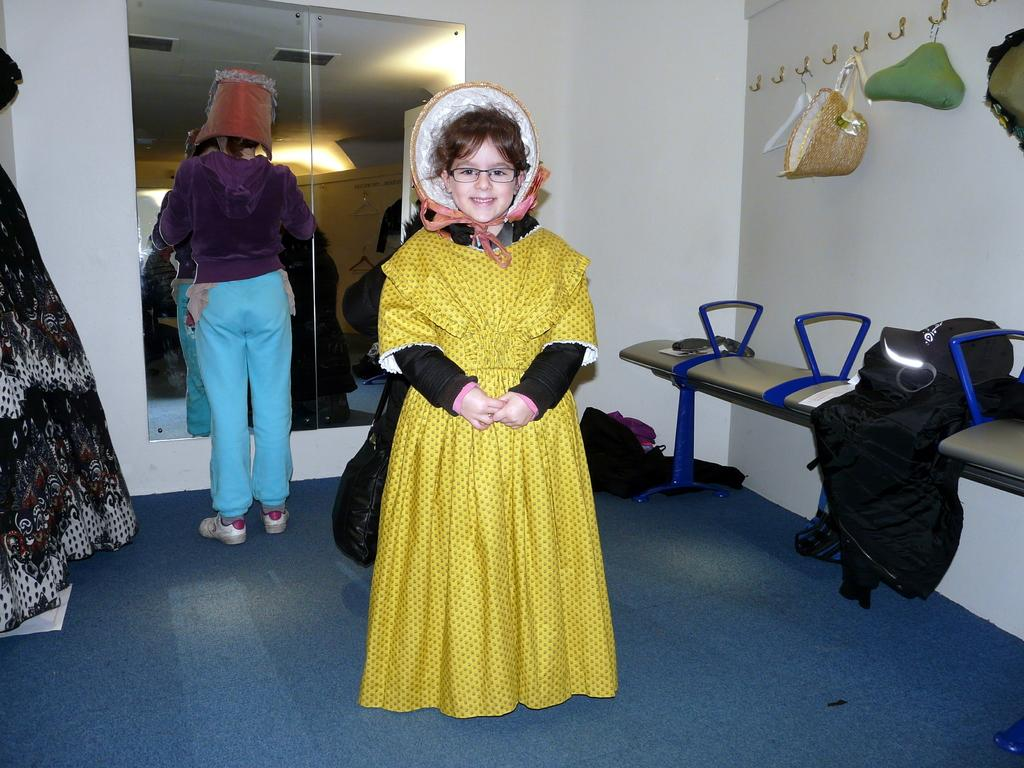What is the main subject of the image? There is a girl standing in the center of the image. What is the girl standing on? The girl is standing on the ground. What can be seen in the background of the image? There are persons, a mirror, hooks, chairs, a hat, clothes, and a wall in the background of the image. What type of activity are the rabbits engaged in during the rainstorm in the image? There are no rabbits or rainstorm present in the image. 